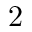Convert formula to latex. <formula><loc_0><loc_0><loc_500><loc_500>2</formula> 